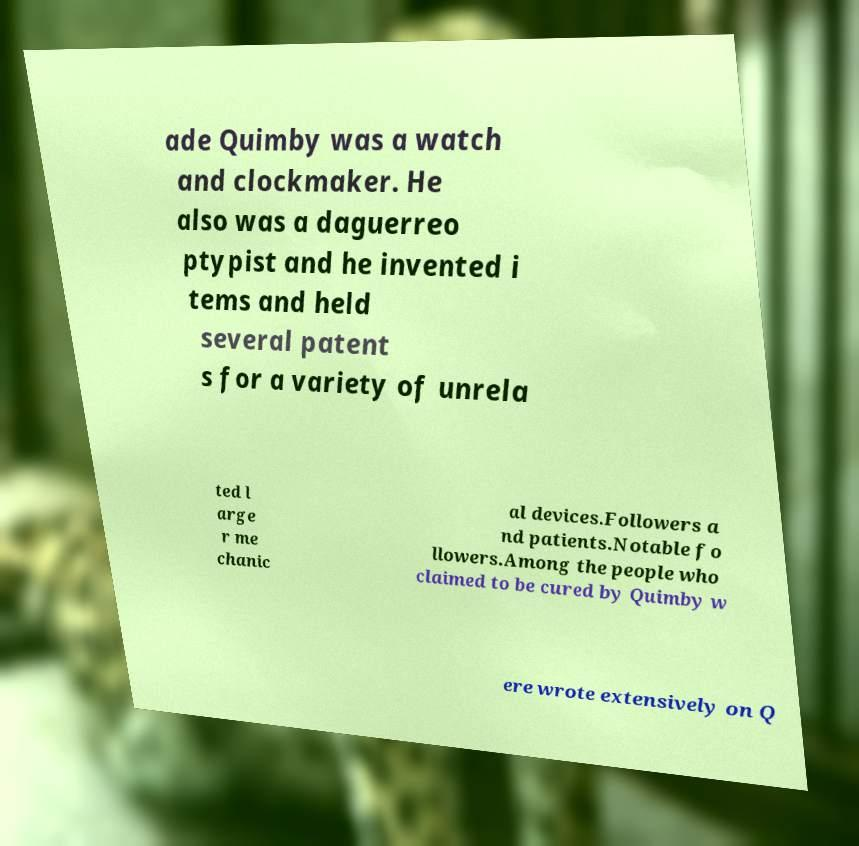I need the written content from this picture converted into text. Can you do that? ade Quimby was a watch and clockmaker. He also was a daguerreo ptypist and he invented i tems and held several patent s for a variety of unrela ted l arge r me chanic al devices.Followers a nd patients.Notable fo llowers.Among the people who claimed to be cured by Quimby w ere wrote extensively on Q 